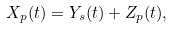Convert formula to latex. <formula><loc_0><loc_0><loc_500><loc_500>X _ { p } ( t ) = Y _ { s } ( t ) + Z _ { p } ( t ) ,</formula> 